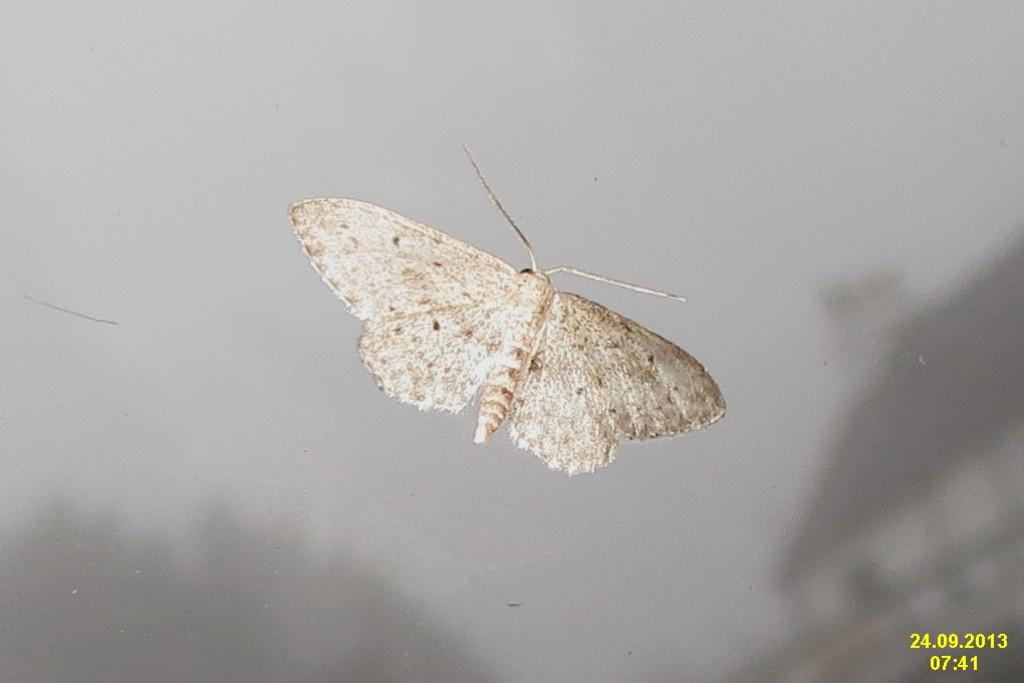What is the main subject of the image? The main subject of the image is a picture of a butterfly. Where is the butterfly located in the image? The butterfly is in the middle of the image. Is there any additional information provided in the image? Yes, there is a date mentioned at the bottom right corner of the image. What type of crime is being committed in the image? There is no crime being committed in the image; it features a picture of a butterfly with a date mentioned at the bottom right corner. What kind of hat is the butterfly wearing in the image? The butterfly is not wearing a hat in the image; it is a picture of a butterfly with no additional accessories. 